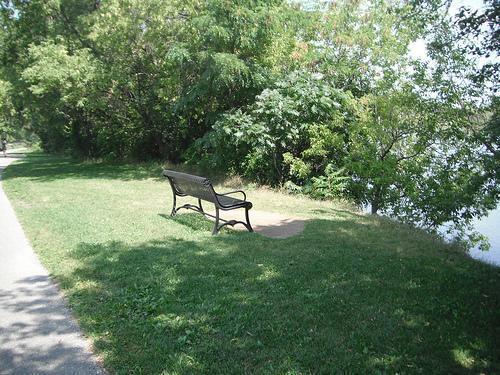How many benches are in this picture?
Give a very brief answer. 1. 